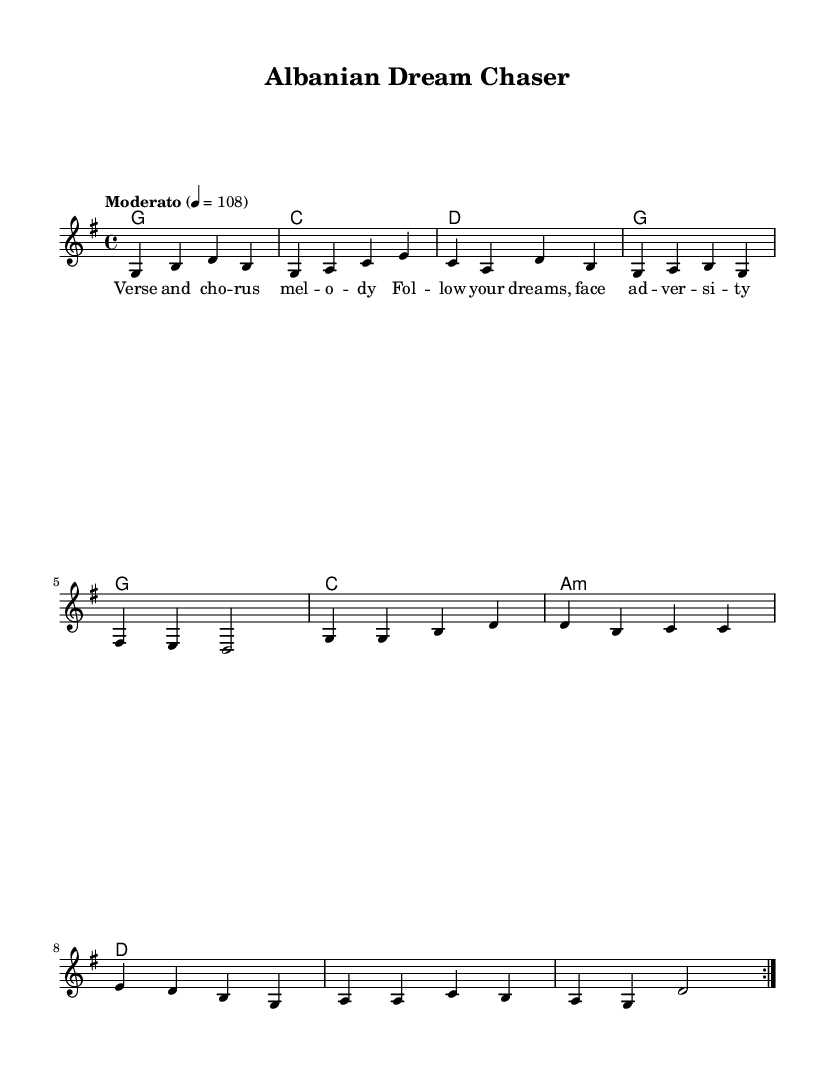What is the key signature of this music? The key signature is G major, which has one sharp (F#). This is determined by looking at the key signature indicated at the beginning of the score.
Answer: G major What is the time signature of this music? The time signature is 4/4, which is indicated at the beginning of the score. This means there are four beats in each measure and the quarter note gets one beat.
Answer: 4/4 What is the tempo marking for this piece? The tempo marking is "Moderato," and it indicates a moderate speed for the piece. This can be found written above the staff.
Answer: Moderato How many measures are there in the melody? Counting the melody notes in the score, there are a total of eight measures repeated once (due to the volta), resulting in a total of eight distinct measures.
Answer: 8 What type of chord follows the G major chord in the progression? The chord that follows the G major chord in the progression is C major, which can be identified by looking at the chord changes written below the melody.
Answer: C major What is the overall theme of the lyrics? The overall theme of the lyrics focuses on following dreams and facing adversity. This can be inferred from the lyrical content provided under the melody, which emphasizes motivation and perseverance.
Answer: Following dreams What musical genre does this piece represent? This piece represents the country rock genre. This can be inferred from the combining elements of country music with rock, which is a distinguishing characteristic of the genre.
Answer: Country rock 